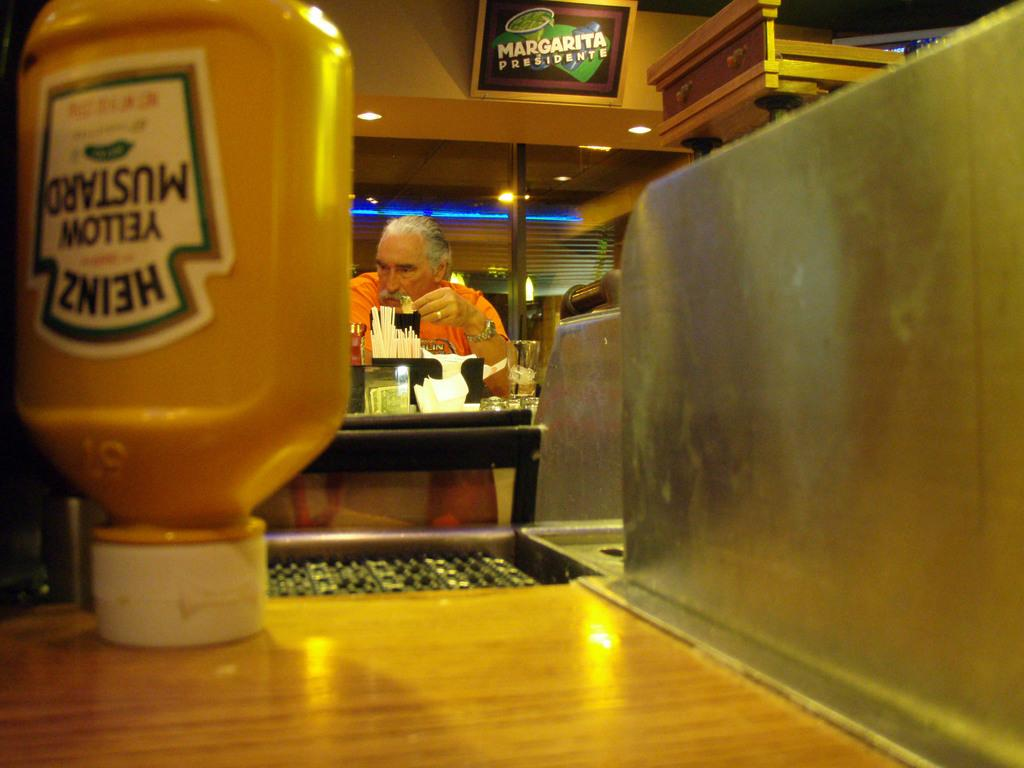<image>
Share a concise interpretation of the image provided. A man at a diner with a bottle of Heinz mustard in front of him 